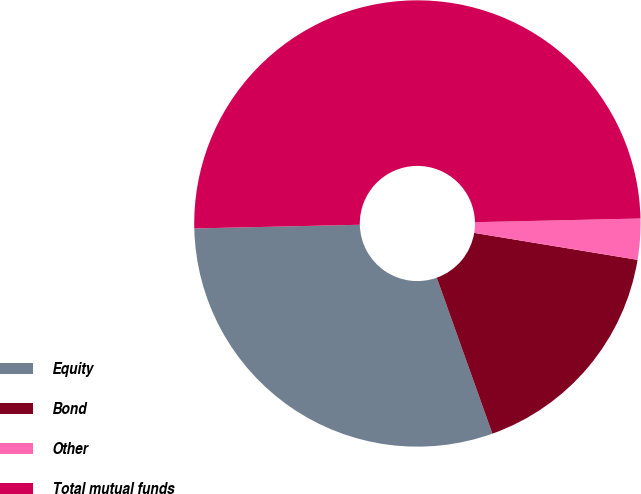Convert chart. <chart><loc_0><loc_0><loc_500><loc_500><pie_chart><fcel>Equity<fcel>Bond<fcel>Other<fcel>Total mutual funds<nl><fcel>30.1%<fcel>16.94%<fcel>2.96%<fcel>50.0%<nl></chart> 